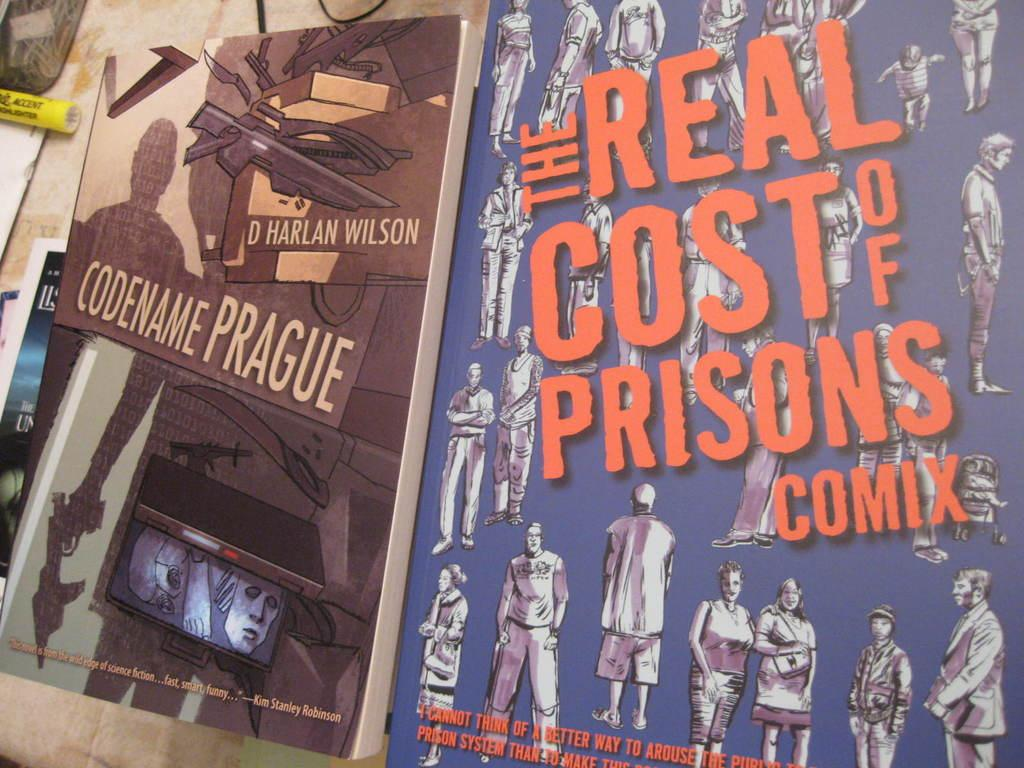<image>
Give a short and clear explanation of the subsequent image. Several paperback books include one selection written by D. Harlan Wilson. 